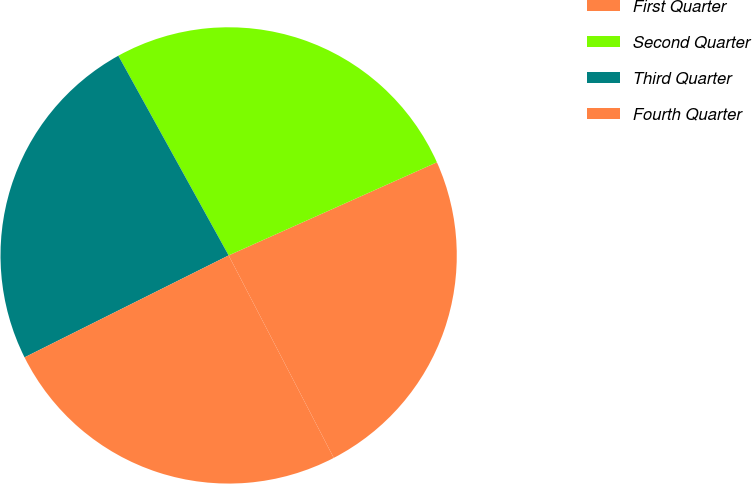Convert chart to OTSL. <chart><loc_0><loc_0><loc_500><loc_500><pie_chart><fcel>First Quarter<fcel>Second Quarter<fcel>Third Quarter<fcel>Fourth Quarter<nl><fcel>24.07%<fcel>26.34%<fcel>24.34%<fcel>25.25%<nl></chart> 